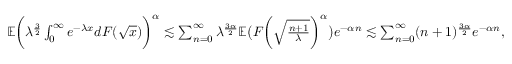<formula> <loc_0><loc_0><loc_500><loc_500>\begin{array} { r } { \mathbb { E } \left ( \lambda ^ { \frac { 3 } { 2 } } \int _ { 0 } ^ { \infty } e ^ { - \lambda x } d F ( \sqrt { x } ) \right ) ^ { \alpha } \lesssim \sum _ { n = 0 } ^ { \infty } \lambda ^ { \frac { 3 \alpha } { 2 } } \mathbb { E } \left ( F \left ( \sqrt { \frac { n + 1 } { \lambda } } \right ) ^ { \alpha } \right ) e ^ { - \alpha n } \lesssim \sum _ { n = 0 } ^ { \infty } ( n + 1 ) ^ { \frac { 3 \alpha } { 2 } } e ^ { - \alpha n } , } \end{array}</formula> 